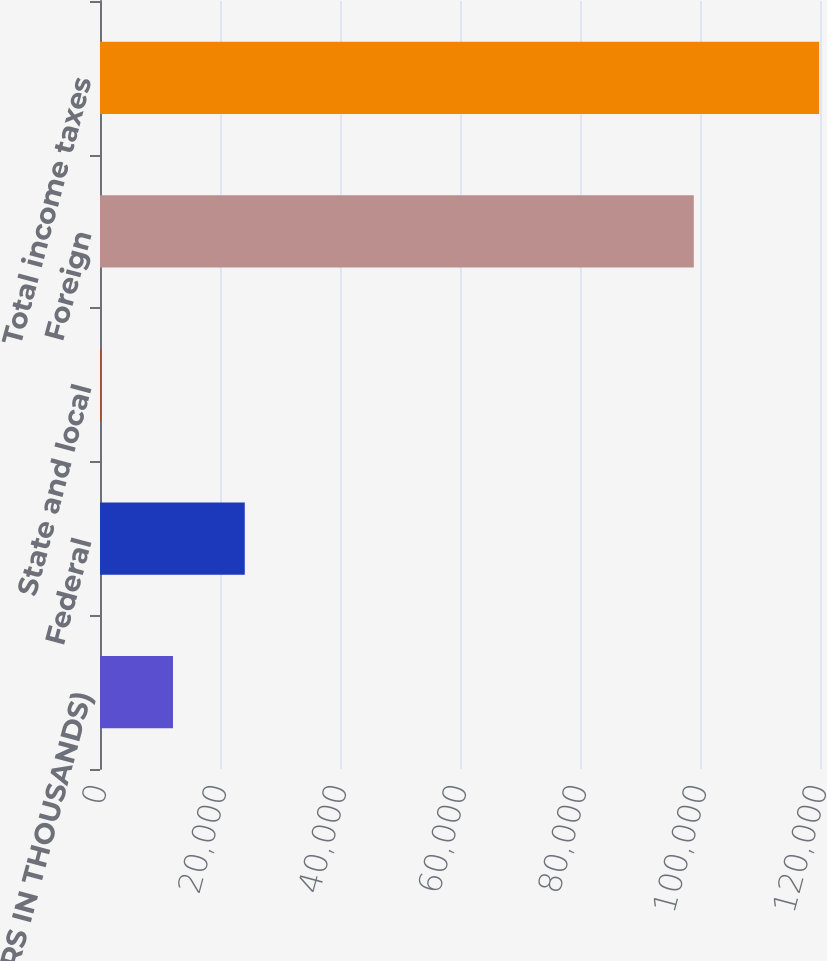<chart> <loc_0><loc_0><loc_500><loc_500><bar_chart><fcel>(DOLLARS IN THOUSANDS)<fcel>Federal<fcel>State and local<fcel>Foreign<fcel>Total income taxes<nl><fcel>12164.5<fcel>24130<fcel>199<fcel>98964<fcel>119854<nl></chart> 